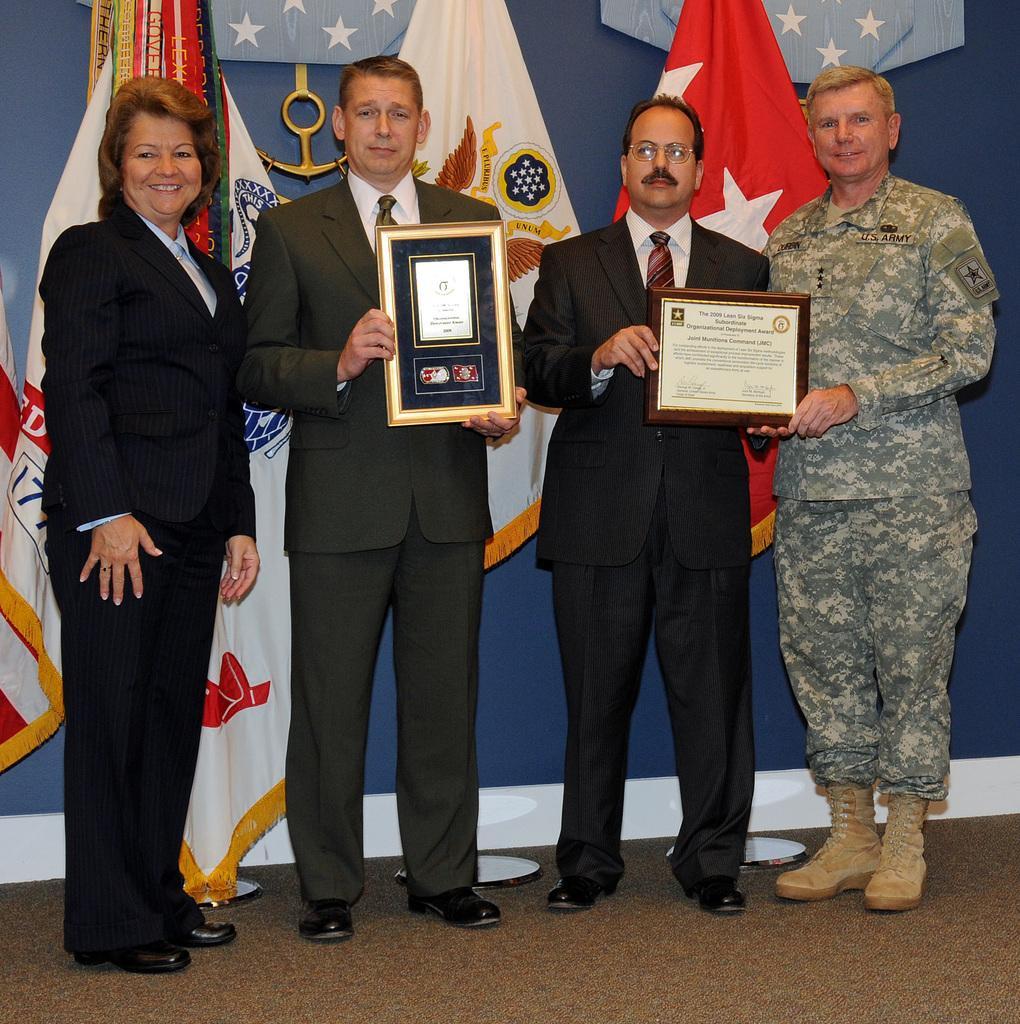Could you give a brief overview of what you see in this image? In this image we can see some persons wearing suit and one of the person wearing army dress holding some awards in their hands and in the background of the image there are some flags and blue color sheet. 